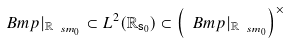<formula> <loc_0><loc_0><loc_500><loc_500>\ B m p | _ { { \mathbb { R } } _ { { \ s m } _ { 0 } } } \subset L ^ { 2 } ( { \mathbb { R } } _ { { \mathsf s } _ { 0 } } ) \subset \left ( \ B m p | _ { { \mathbb { R } } _ { { \ s m } _ { 0 } } } \right ) ^ { \times }</formula> 